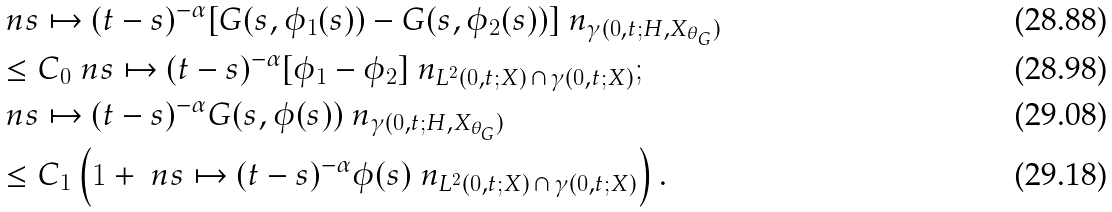<formula> <loc_0><loc_0><loc_500><loc_500>& \quad \ n s \mapsto ( t - s ) ^ { - \alpha } [ G ( s , \phi _ { 1 } ( s ) ) - G ( s , \phi _ { 2 } ( s ) ) ] \ n _ { \gamma ( 0 , t ; H , X _ { \theta _ { G } } ) } \\ & \quad \leq C _ { 0 } \ n s \mapsto ( t - s ) ^ { - \alpha } [ \phi _ { 1 } - \phi _ { 2 } ] \ n _ { L ^ { 2 } ( 0 , t ; X ) \, \cap \, \gamma ( 0 , t ; X ) } ; \\ & \quad \ n s \mapsto ( t - s ) ^ { - \alpha } G ( s , \phi ( s ) ) \ n _ { \gamma ( 0 , t ; H , X _ { \theta _ { G } } ) } \\ & \quad \leq C _ { 1 } \left ( 1 + \ n s \mapsto ( t - s ) ^ { - \alpha } \phi ( s ) \ n _ { L ^ { 2 } ( 0 , t ; X ) \, \cap \, \gamma ( 0 , t ; X ) } \right ) .</formula> 